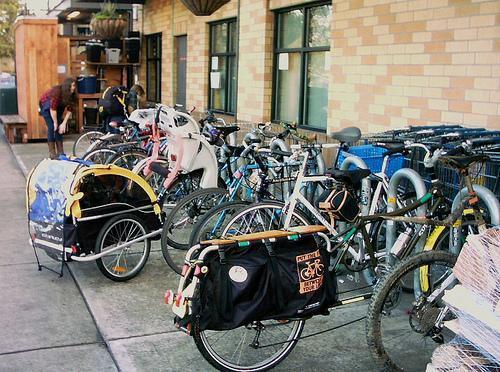How many people in this photo have long hair?
Give a very brief answer. 1. How many bicycles are there?
Give a very brief answer. 8. 